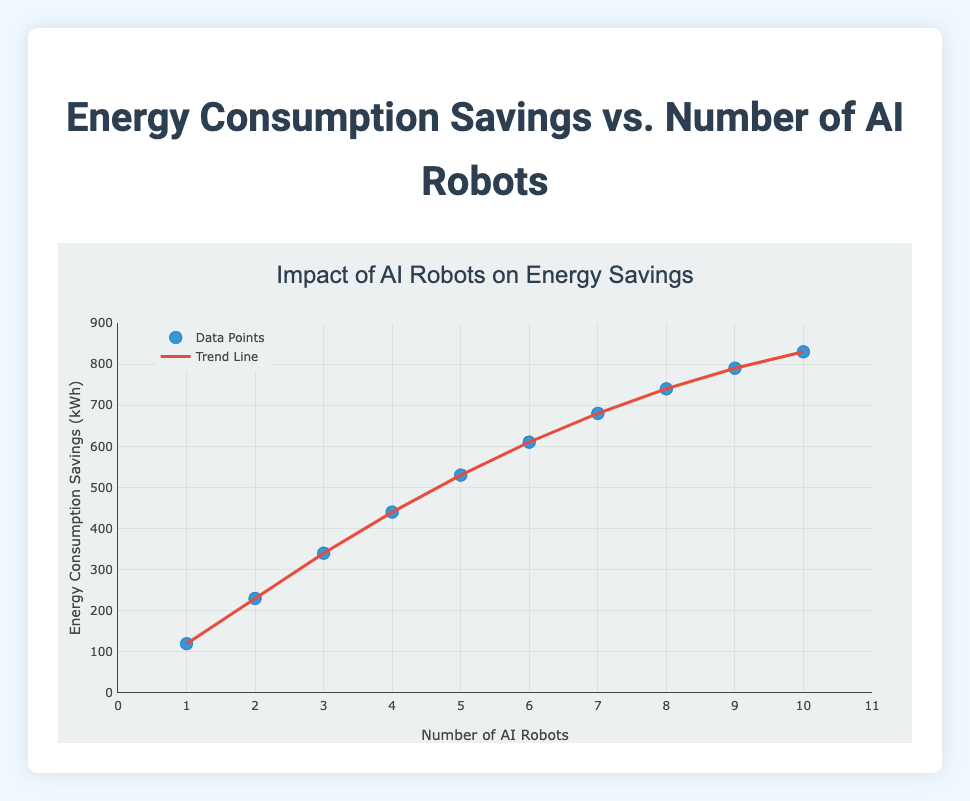What is the title of the figure? The title of the figure is displayed at the top and reads "Impact of AI Robots on Energy Savings".
Answer: Impact of AI Robots on Energy Savings How many AI robots were used in the data? To determine the number of AI robots, we count the distinct number of points along the x-axis, which goes from 1 to 10.
Answer: 10 What is the unit of measurement for Energy Consumption Savings? The y-axis title provides the unit of measurement, which is "Energy Consumption Savings (kWh)".
Answer: kWh What's the range of the x-axis? Looking at the x-axis, the tick marks start from 0 and go up to 11.
Answer: 0 to 11 What is the trend in energy consumption savings as the number of AI robots increases? By examining the trend line which slopes upwards, it indicates that energy consumption savings increase as the number of AI robots increases.
Answer: Increases What is the energy consumption savings when there are 5 AI robots? Locate the data point corresponding to 5 AI robots on the x-axis and trace upwards to the y-axis value, which indicates 530 kWh savings.
Answer: 530 kWh By how much does the energy consumption savings increase from 1 AI robot to 10 AI robots? At 1 AI robot, the savings are 120 kWh. At 10 AI robots, the savings are 830 kWh. The difference is 830 - 120 = 710 kWh.
Answer: 710 kWh Which number of AI robots corresponds to the highest energy consumption savings? The data point with the highest y-value (830 kWh) corresponds to 10 AI robots.
Answer: 10 Are there more noticeable savings in energy consumption as the number of AI robots increases, based on the trend line? By examining the trend line, it shows a consistent upward pattern, indicating that increased AI robots correlate with noticeable energy savings.
Answer: Yes Is the relationship between the number of AI robots and energy consumption savings linear or non-linear? Observing the trend line, which is a straight line, suggests that the relationship is linear.
Answer: Linear 